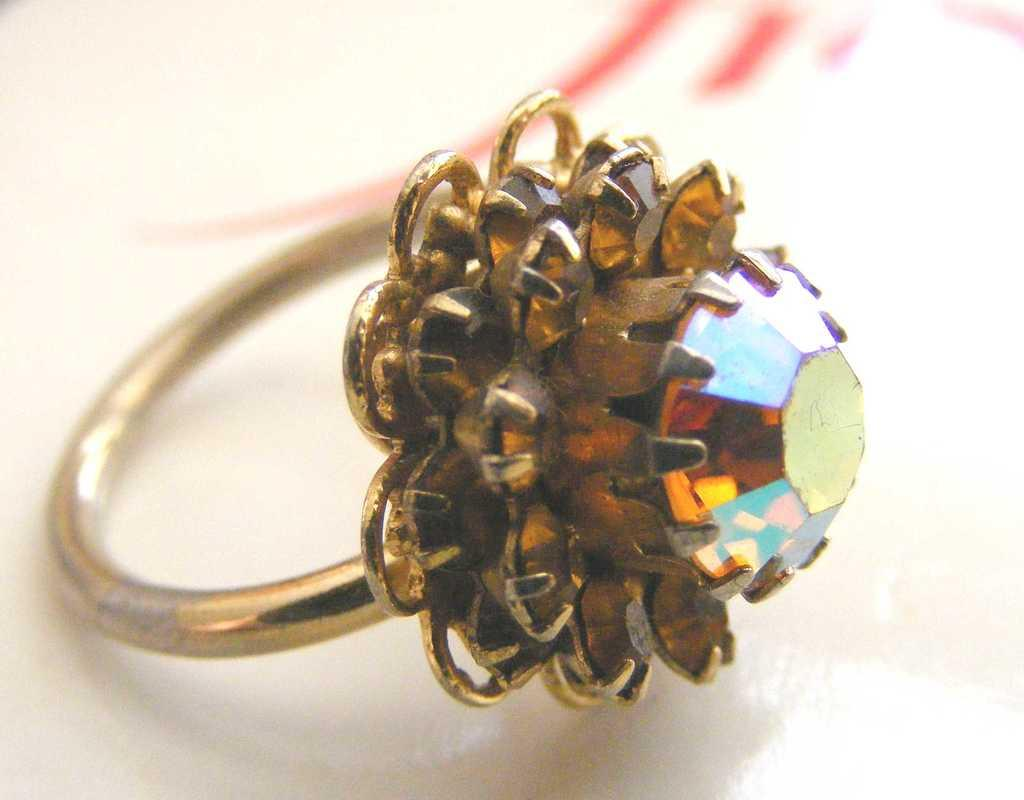What type of jewelry is present in the image? There is a finger ring in the picture. What is the color of the ring? The ring is golden in color. Does the ring have any additional features? Yes, the ring has a gem. On what surface is the ring placed? The ring is placed on a white surface. Can you tell me how many muscles are visible in the image? There are no muscles visible in the image, as it features a finger ring placed on a white surface. 